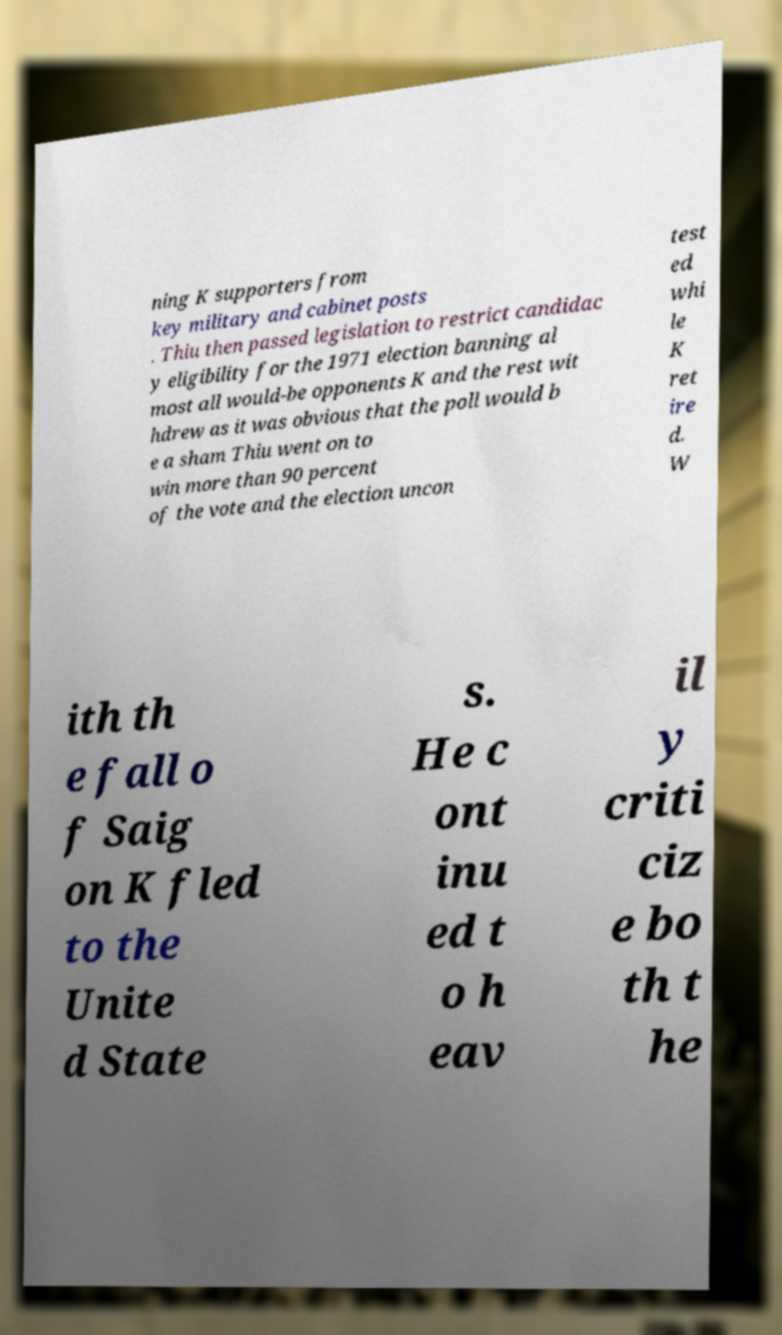Please identify and transcribe the text found in this image. ning K supporters from key military and cabinet posts . Thiu then passed legislation to restrict candidac y eligibility for the 1971 election banning al most all would-be opponents K and the rest wit hdrew as it was obvious that the poll would b e a sham Thiu went on to win more than 90 percent of the vote and the election uncon test ed whi le K ret ire d. W ith th e fall o f Saig on K fled to the Unite d State s. He c ont inu ed t o h eav il y criti ciz e bo th t he 